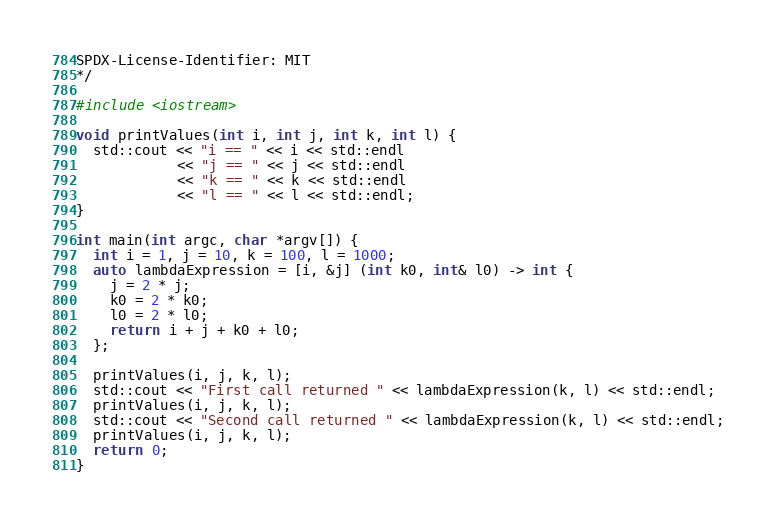<code> <loc_0><loc_0><loc_500><loc_500><_C++_>
SPDX-License-Identifier: MIT
*/

#include <iostream>

void printValues(int i, int j, int k, int l) {
  std::cout << "i == " << i << std::endl
            << "j == " << j << std::endl
            << "k == " << k << std::endl
            << "l == " << l << std::endl;
}

int main(int argc, char *argv[]) {
  int i = 1, j = 10, k = 100, l = 1000;
  auto lambdaExpression = [i, &j] (int k0, int& l0) -> int {
    j = 2 * j;
    k0 = 2 * k0;
    l0 = 2 * l0;
    return i + j + k0 + l0;
  };

  printValues(i, j, k, l);
  std::cout << "First call returned " << lambdaExpression(k, l) << std::endl;
  printValues(i, j, k, l);
  std::cout << "Second call returned " << lambdaExpression(k, l) << std::endl;
  printValues(i, j, k, l);
  return 0;
}

</code> 